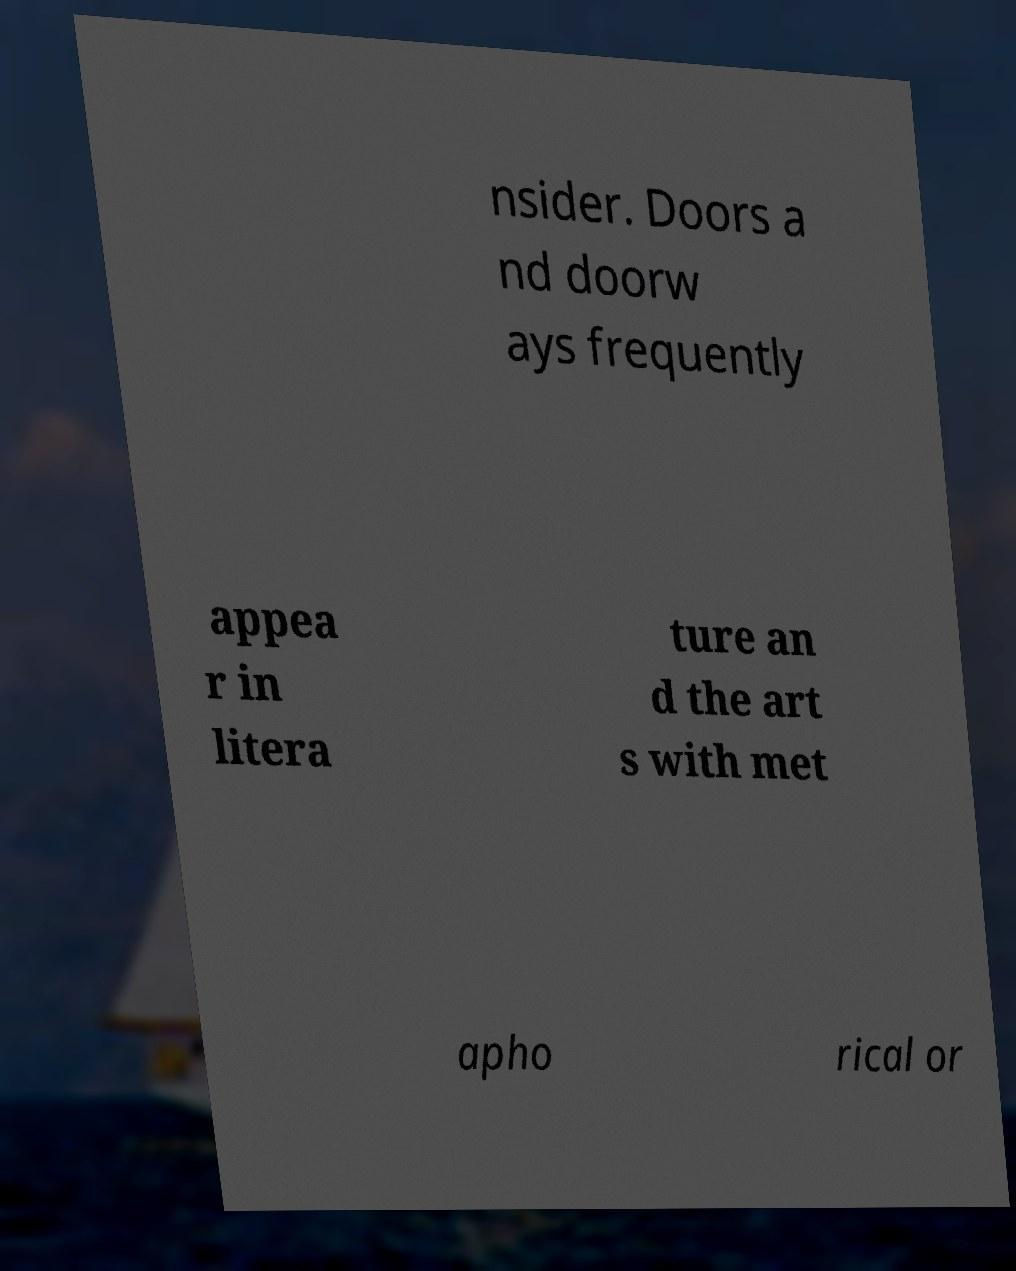For documentation purposes, I need the text within this image transcribed. Could you provide that? nsider. Doors a nd doorw ays frequently appea r in litera ture an d the art s with met apho rical or 